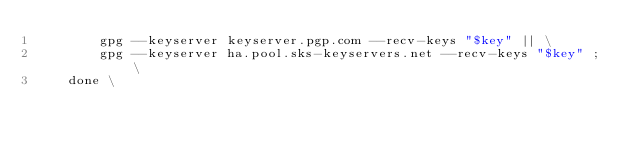<code> <loc_0><loc_0><loc_500><loc_500><_Dockerfile_>		gpg --keyserver keyserver.pgp.com --recv-keys "$key" || \
		gpg --keyserver ha.pool.sks-keyservers.net --recv-keys "$key" ; \
	done \</code> 